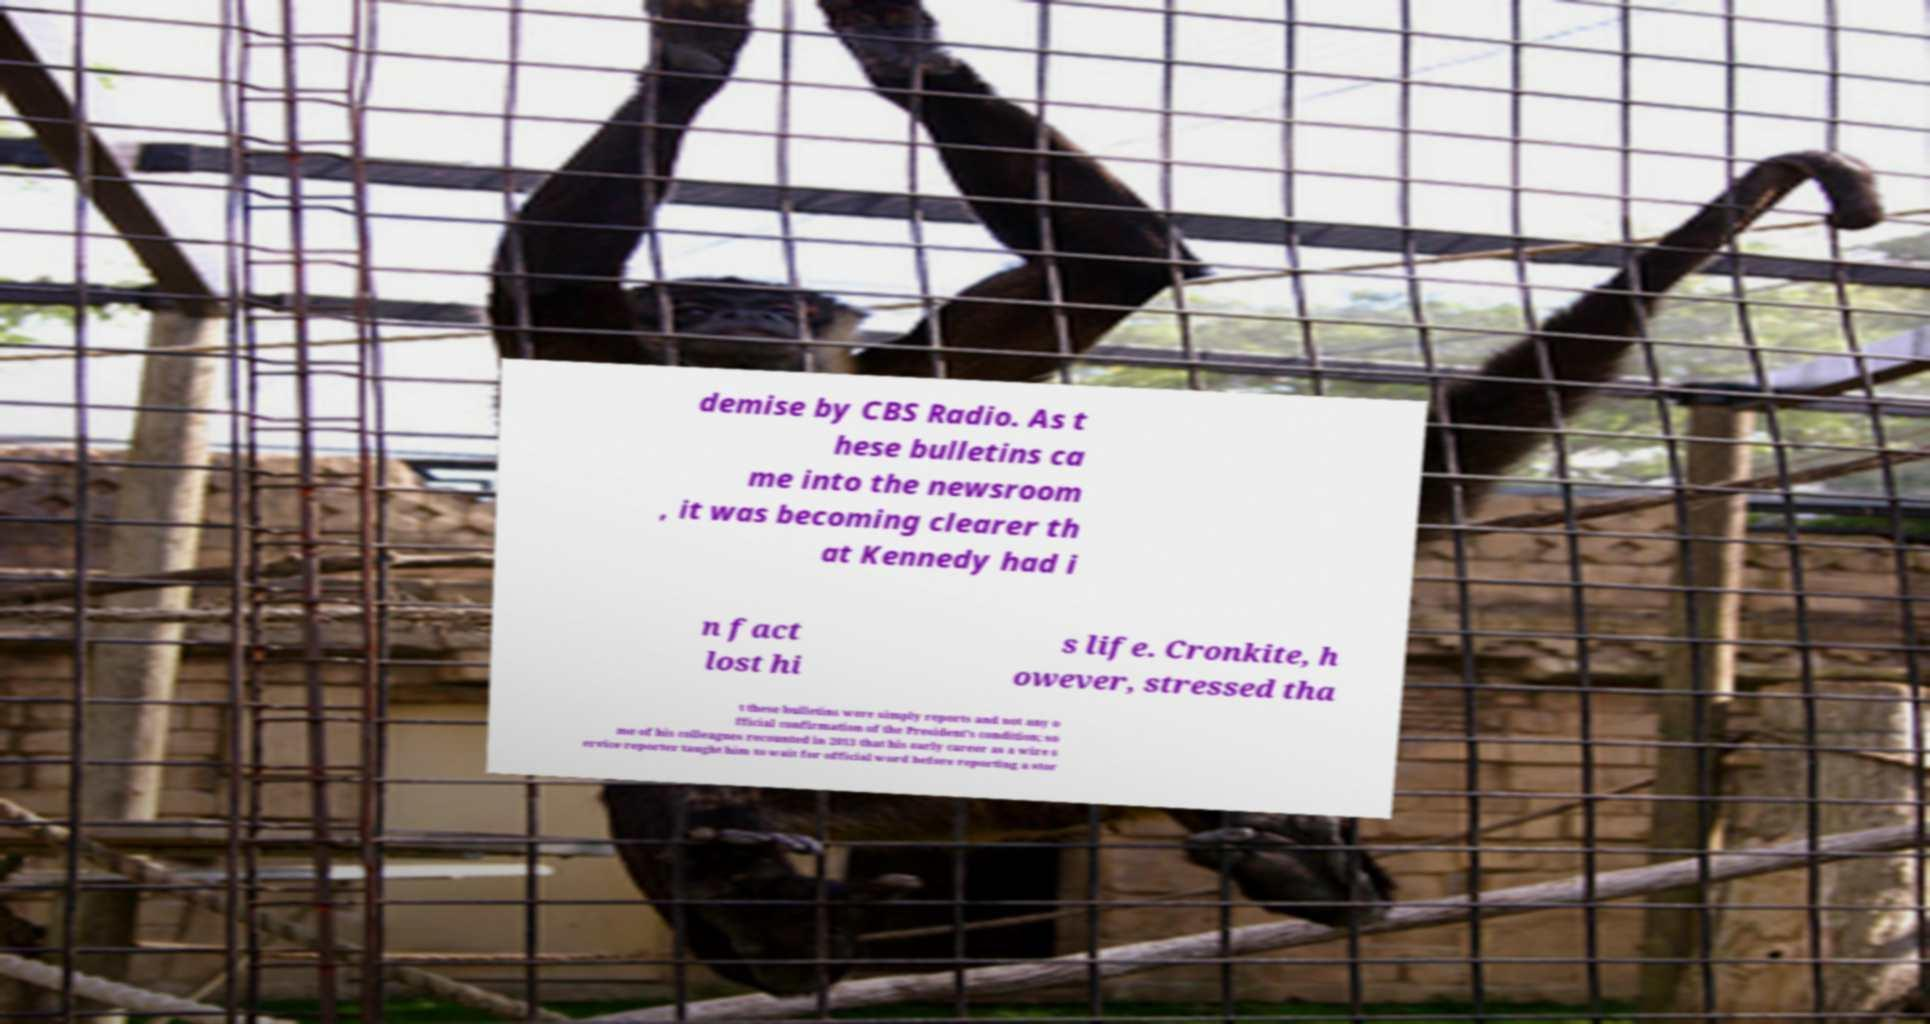Can you accurately transcribe the text from the provided image for me? demise by CBS Radio. As t hese bulletins ca me into the newsroom , it was becoming clearer th at Kennedy had i n fact lost hi s life. Cronkite, h owever, stressed tha t these bulletins were simply reports and not any o fficial confirmation of the President's condition; so me of his colleagues recounted in 2013 that his early career as a wire s ervice reporter taught him to wait for official word before reporting a stor 